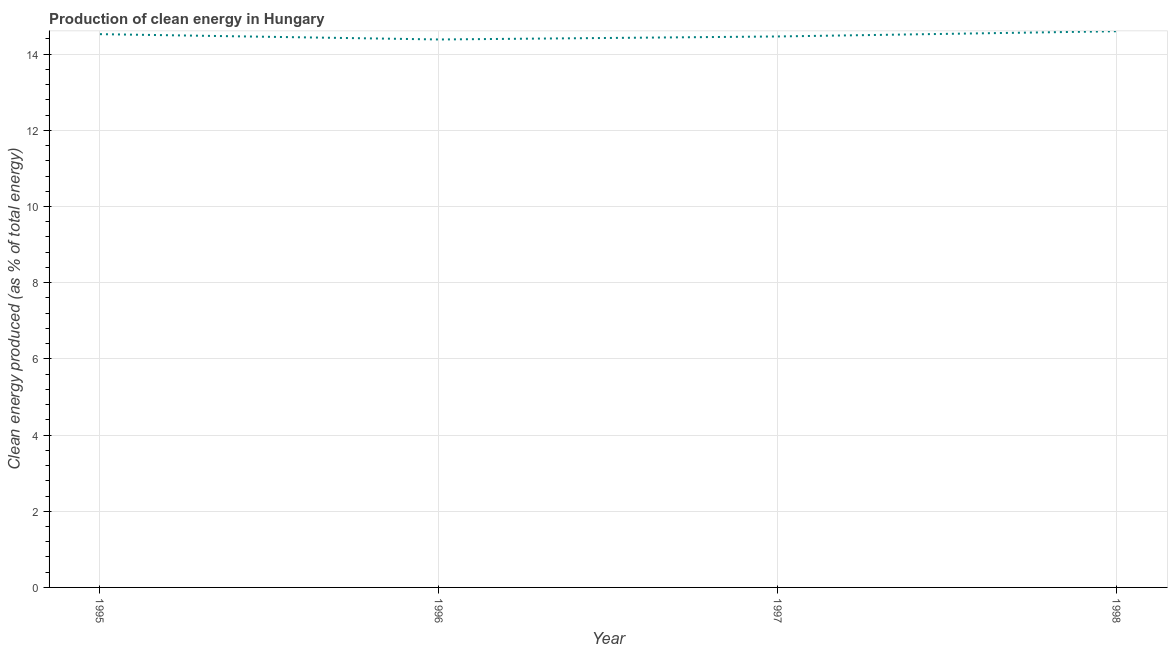What is the production of clean energy in 1995?
Your answer should be very brief. 14.52. Across all years, what is the maximum production of clean energy?
Offer a very short reply. 14.6. Across all years, what is the minimum production of clean energy?
Your answer should be very brief. 14.39. What is the sum of the production of clean energy?
Your answer should be compact. 57.98. What is the difference between the production of clean energy in 1997 and 1998?
Keep it short and to the point. -0.14. What is the average production of clean energy per year?
Provide a succinct answer. 14.49. What is the median production of clean energy?
Provide a short and direct response. 14.49. In how many years, is the production of clean energy greater than 9.6 %?
Provide a succinct answer. 4. What is the ratio of the production of clean energy in 1995 to that in 1996?
Keep it short and to the point. 1.01. Is the production of clean energy in 1996 less than that in 1997?
Provide a succinct answer. Yes. Is the difference between the production of clean energy in 1996 and 1997 greater than the difference between any two years?
Your answer should be very brief. No. What is the difference between the highest and the second highest production of clean energy?
Offer a terse response. 0.08. Is the sum of the production of clean energy in 1995 and 1996 greater than the maximum production of clean energy across all years?
Your response must be concise. Yes. What is the difference between the highest and the lowest production of clean energy?
Provide a succinct answer. 0.22. Does the production of clean energy monotonically increase over the years?
Keep it short and to the point. No. How many lines are there?
Offer a very short reply. 1. How many years are there in the graph?
Provide a short and direct response. 4. What is the difference between two consecutive major ticks on the Y-axis?
Your answer should be very brief. 2. What is the title of the graph?
Provide a succinct answer. Production of clean energy in Hungary. What is the label or title of the X-axis?
Offer a terse response. Year. What is the label or title of the Y-axis?
Offer a very short reply. Clean energy produced (as % of total energy). What is the Clean energy produced (as % of total energy) of 1995?
Keep it short and to the point. 14.52. What is the Clean energy produced (as % of total energy) of 1996?
Your answer should be compact. 14.39. What is the Clean energy produced (as % of total energy) in 1997?
Provide a succinct answer. 14.46. What is the Clean energy produced (as % of total energy) of 1998?
Offer a terse response. 14.6. What is the difference between the Clean energy produced (as % of total energy) in 1995 and 1996?
Provide a short and direct response. 0.14. What is the difference between the Clean energy produced (as % of total energy) in 1995 and 1997?
Ensure brevity in your answer.  0.06. What is the difference between the Clean energy produced (as % of total energy) in 1995 and 1998?
Provide a short and direct response. -0.08. What is the difference between the Clean energy produced (as % of total energy) in 1996 and 1997?
Ensure brevity in your answer.  -0.08. What is the difference between the Clean energy produced (as % of total energy) in 1996 and 1998?
Give a very brief answer. -0.22. What is the difference between the Clean energy produced (as % of total energy) in 1997 and 1998?
Ensure brevity in your answer.  -0.14. What is the ratio of the Clean energy produced (as % of total energy) in 1995 to that in 1998?
Keep it short and to the point. 0.99. What is the ratio of the Clean energy produced (as % of total energy) in 1996 to that in 1997?
Make the answer very short. 0.99. What is the ratio of the Clean energy produced (as % of total energy) in 1996 to that in 1998?
Ensure brevity in your answer.  0.98. What is the ratio of the Clean energy produced (as % of total energy) in 1997 to that in 1998?
Your response must be concise. 0.99. 